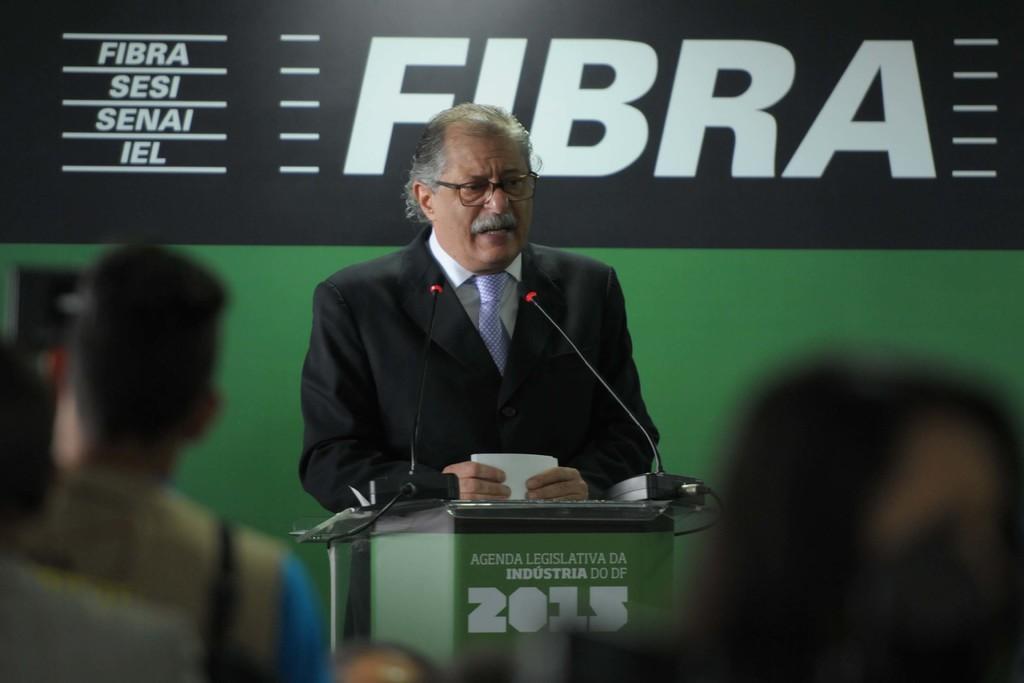Could you give a brief overview of what you see in this image? In the center of the image there is a person standing at the desk holding a papers. At the bottom of the image we can see a person's head. On the left side of the image there is a person. In the background there is an advertisement. 